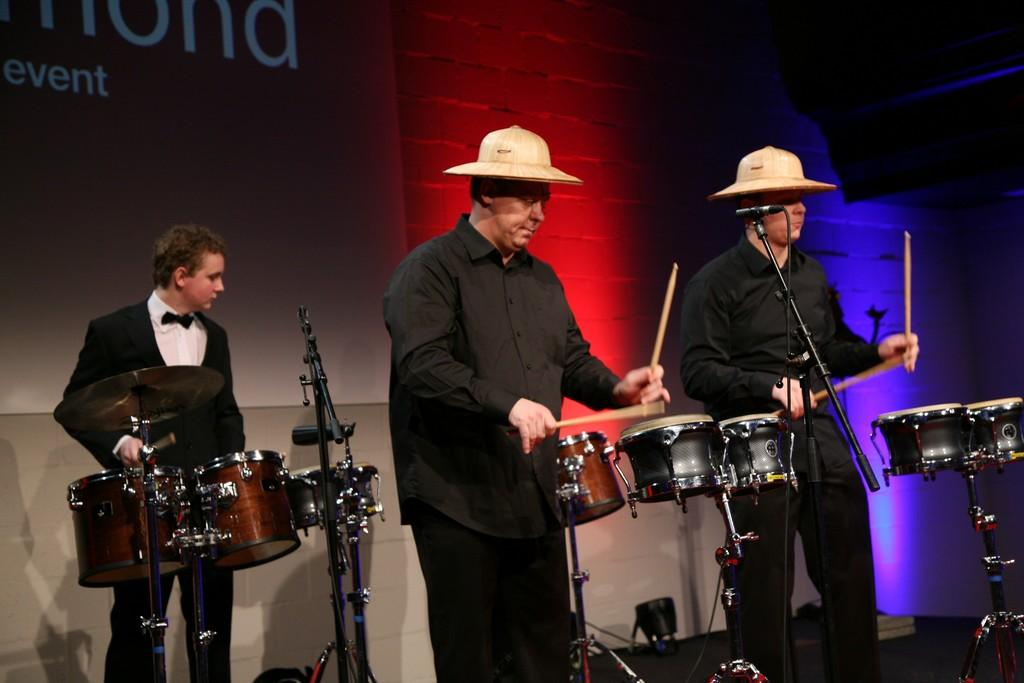What are the people in the image doing? The people in the image are playing drums. What equipment is visible in the image that might be used for amplifying sound? There are microphones with stands in the image. What can be seen in the background of the image? There is a screen and a wall in the background of the image. What is on the floor in the image? There are objects on the floor in the image. Can you tell me how many snails are crawling on the wall in the image? There are no snails present in the image; the wall is part of the background and does not have any snails on it. 